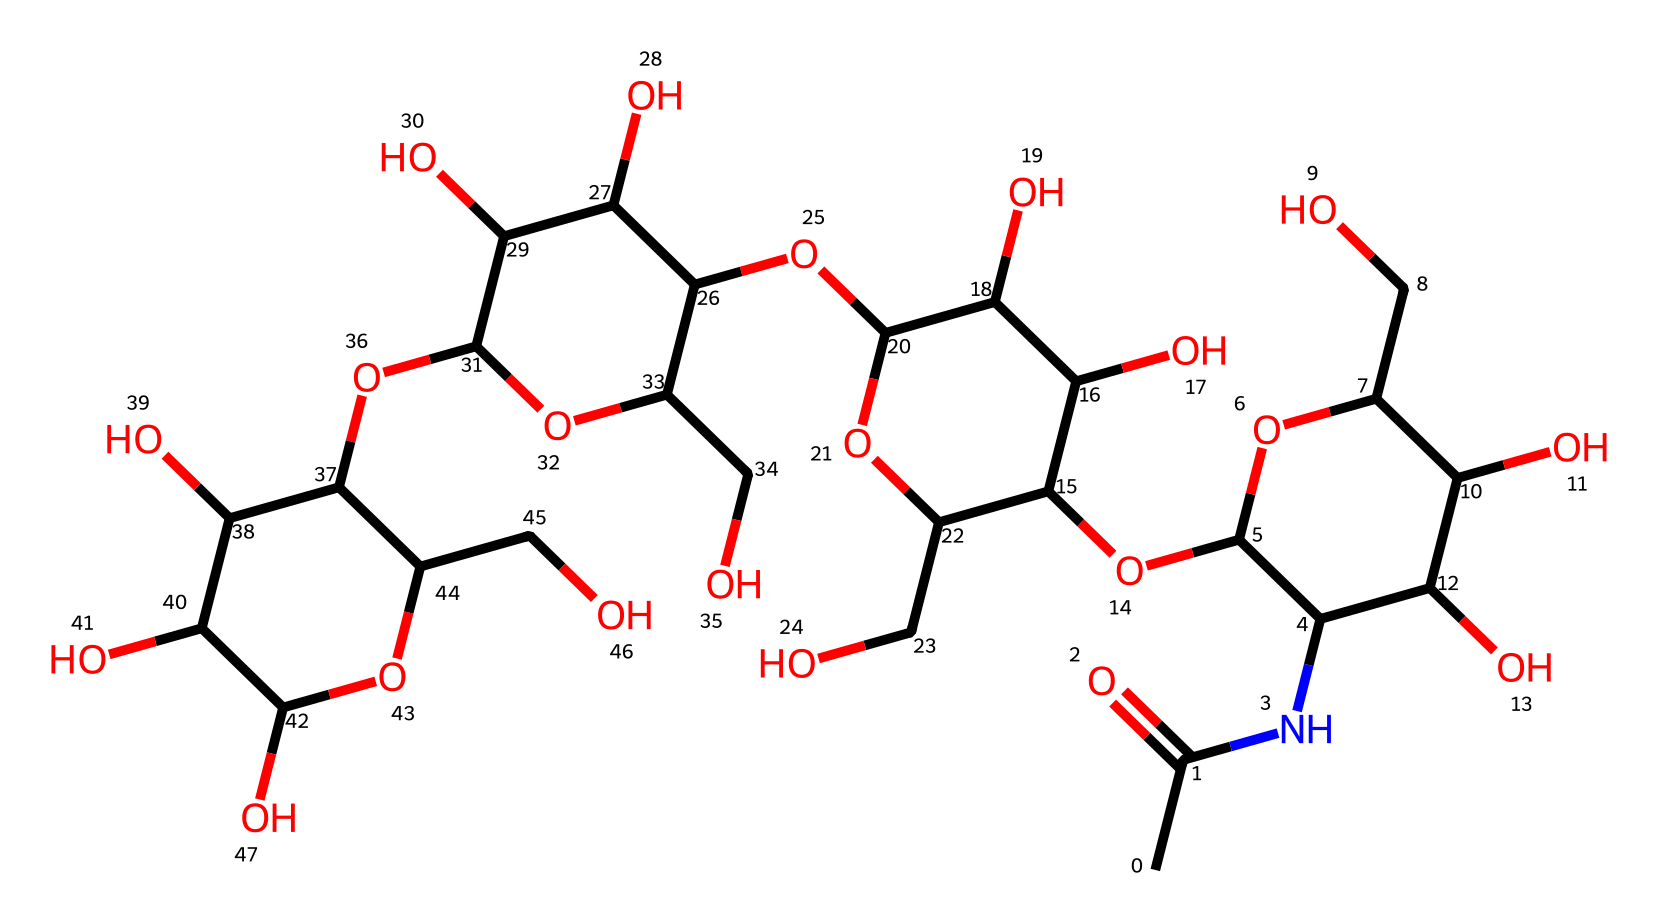what is the chemical name of this compound? This chemical structure corresponds to hyaluronic acid, a known moisturizing agent commonly found in cosmetic formulations. The presence of the functional groups and the overall structure indicate its designation.
Answer: hyaluronic acid how many carbon atoms are present in the structure? By analyzing the SMILES representation, we can count the number of carbon 'C' atoms. The representation indicates 16 carbon atoms in total.
Answer: 16 how many hydroxyl (OH) groups are present in the molecule? A hydroxyl group consists of an oxygen atom bonded to a hydrogen atom (—OH). In the chemical structure, several —OH groups can be identified by the presence of oxygen atoms bonded to carbons, leading to a total of 8 hydroxyl groups in this compound.
Answer: 8 what is the primary function of hyaluronic acid in cosmetic applications? Hyaluronic acid primarily functions as a humectant in cosmetic products, which means it helps retain moisture in the skin by attracting water molecules. This is due to its hydrophilic nature attributed to its hydroxyl groups.
Answer: humectant how do the rings in the structure contribute to the properties of hyaluronic acid? The rings in the structure of hyaluronic acid contribute to its stability and create a specific conformation, which enhances its ability to provide skin hydration. The cyclic structure allows for effective interaction with the skin's extracellular matrix, enhancing moisture retention.
Answer: stability and hydration what type of chemical bond is predominantly found in hyaluronic acid? The predominant type of chemical bond in hyaluronic acid is the glycosidic bond, which connects the monosaccharide units. These bonds are essential for the structure and function of hyaluronic acid in retaining moisture within skin cells.
Answer: glycosidic bond 